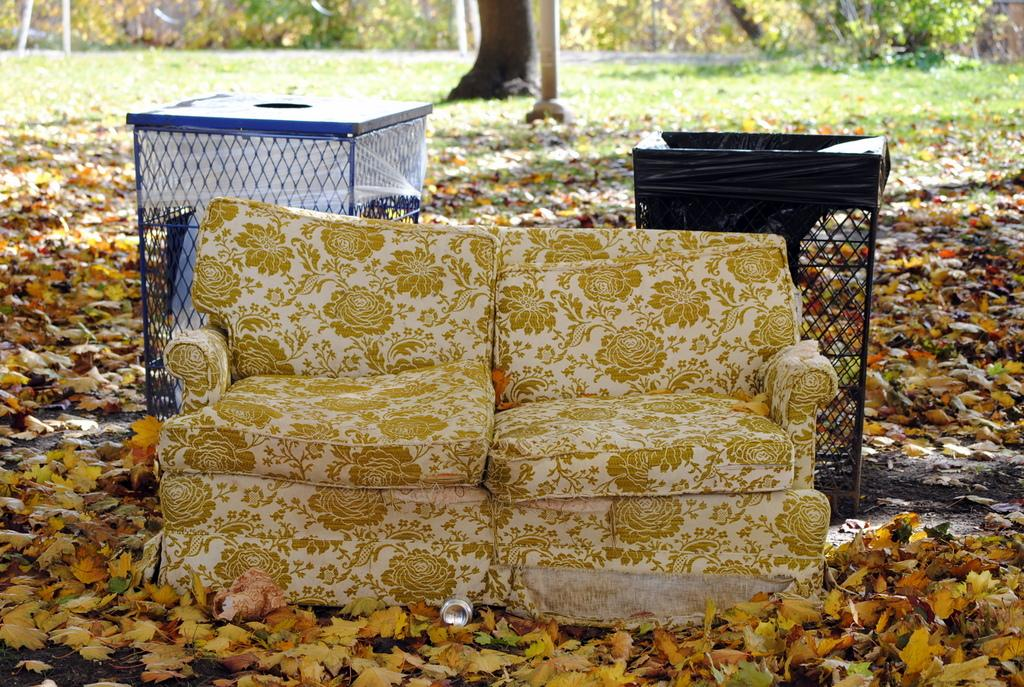What type of furniture is present in the image? There is a sofa in the image. What objects are used for waste disposal in the image? There are two bins in the image. What type of natural environment is visible in the image? There are leaves on the ground, grass, and trees visible in the image. What flavor of secretary can be seen working in the image? There is no secretary present in the image, and therefore no flavor can be associated with it. 